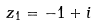<formula> <loc_0><loc_0><loc_500><loc_500>z _ { 1 } = - 1 + i</formula> 